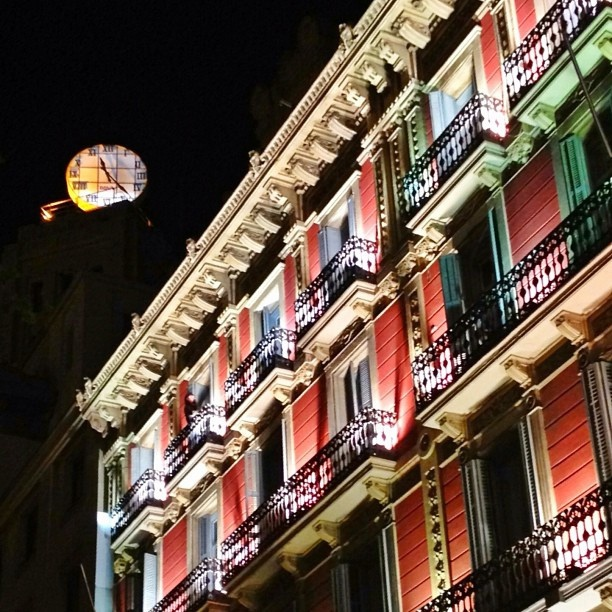Describe the objects in this image and their specific colors. I can see a clock in black, lightgray, tan, and darkgray tones in this image. 